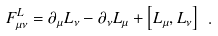Convert formula to latex. <formula><loc_0><loc_0><loc_500><loc_500>F _ { \mu \nu } ^ { L } = \partial _ { \mu } L _ { \nu } - \partial _ { \nu } L _ { \mu } + \left [ L _ { \mu } , L _ { \nu } \right ] \ .</formula> 